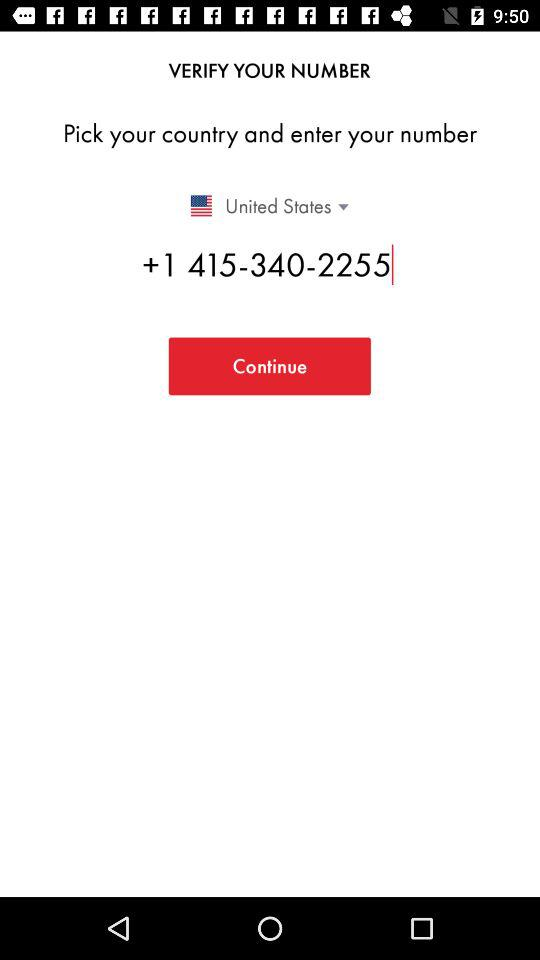What is the contact number given on the screen? The contact number given on the screen is +1 415-340-2255. 